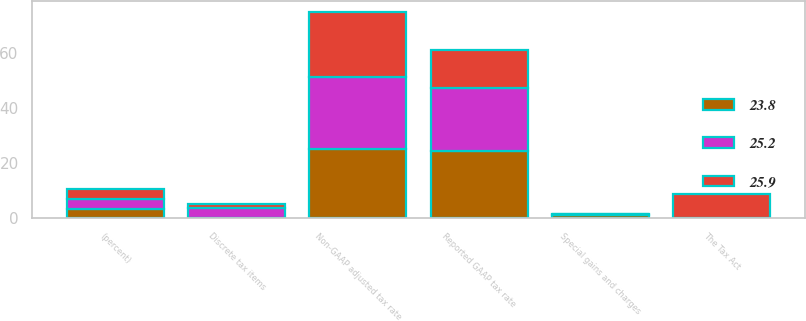Convert chart to OTSL. <chart><loc_0><loc_0><loc_500><loc_500><stacked_bar_chart><ecel><fcel>(percent)<fcel>Reported GAAP tax rate<fcel>The Tax Act<fcel>Special gains and charges<fcel>Discrete tax items<fcel>Non-GAAP adjusted tax rate<nl><fcel>25.9<fcel>3.5<fcel>13.7<fcel>8.8<fcel>0.1<fcel>1.4<fcel>23.8<nl><fcel>23.8<fcel>3.5<fcel>24.4<fcel>0<fcel>1<fcel>0.2<fcel>25.2<nl><fcel>25.2<fcel>3.5<fcel>22.8<fcel>0<fcel>0.4<fcel>3.5<fcel>25.9<nl></chart> 